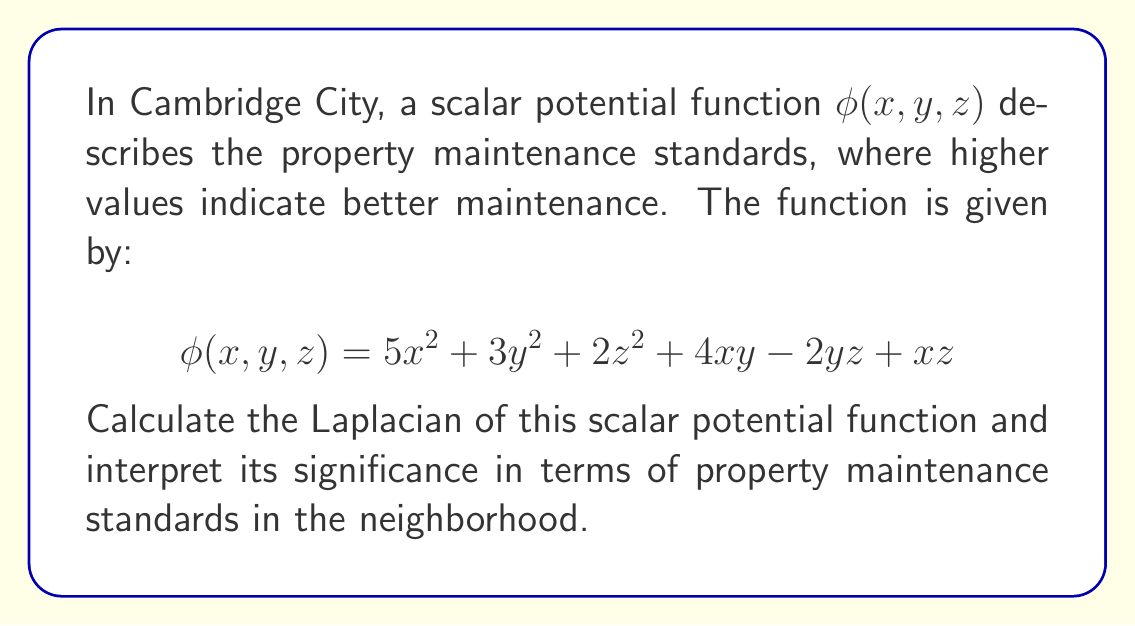Give your solution to this math problem. To solve this problem, we'll follow these steps:

1) The Laplacian of a scalar function in 3D is given by:

   $$\nabla^2\phi = \frac{\partial^2\phi}{\partial x^2} + \frac{\partial^2\phi}{\partial y^2} + \frac{\partial^2\phi}{\partial z^2}$$

2) Let's calculate each second partial derivative:

   a) $\frac{\partial^2\phi}{\partial x^2}$:
      $\frac{\partial\phi}{\partial x} = 10x + 4y + z$
      $\frac{\partial^2\phi}{\partial x^2} = 10$

   b) $\frac{\partial^2\phi}{\partial y^2}$:
      $\frac{\partial\phi}{\partial y} = 6y + 4x - 2z$
      $\frac{\partial^2\phi}{\partial y^2} = 6$

   c) $\frac{\partial^2\phi}{\partial z^2}$:
      $\frac{\partial\phi}{\partial z} = 4z - 2y + x$
      $\frac{\partial^2\phi}{\partial z^2} = 4$

3) Now, we sum these second partial derivatives:

   $$\nabla^2\phi = 10 + 6 + 4 = 20$$

4) Interpretation: The Laplacian being a positive constant (20) indicates that the property maintenance standards are generally high and uniform across the neighborhood. This aligns with the persona's perception of an orderly and clean neighborhood. The positive value suggests that the maintenance standards tend to be higher than the average of the surrounding areas, contributing to the overall cleanliness and order of the Cambridge City neighborhood.
Answer: $\nabla^2\phi = 20$ 